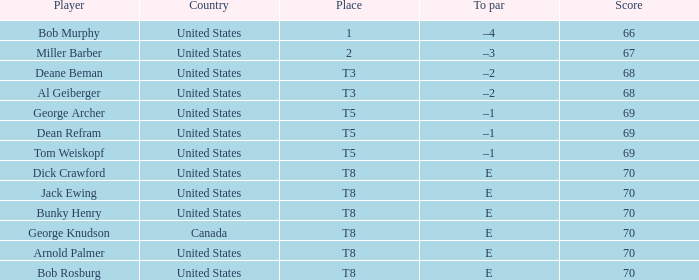When Bunky Henry of the United States scored higher than 67 and his To par was e, what was his place? T8. 